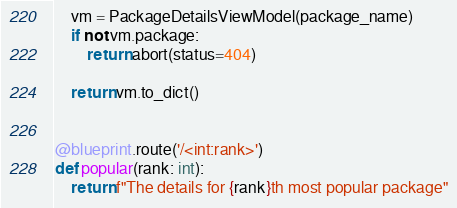<code> <loc_0><loc_0><loc_500><loc_500><_Python_>    vm = PackageDetailsViewModel(package_name)
    if not vm.package:
        return abort(status=404)

    return vm.to_dict()


@blueprint.route('/<int:rank>')
def popular(rank: int):
    return f"The details for {rank}th most popular package"
</code> 